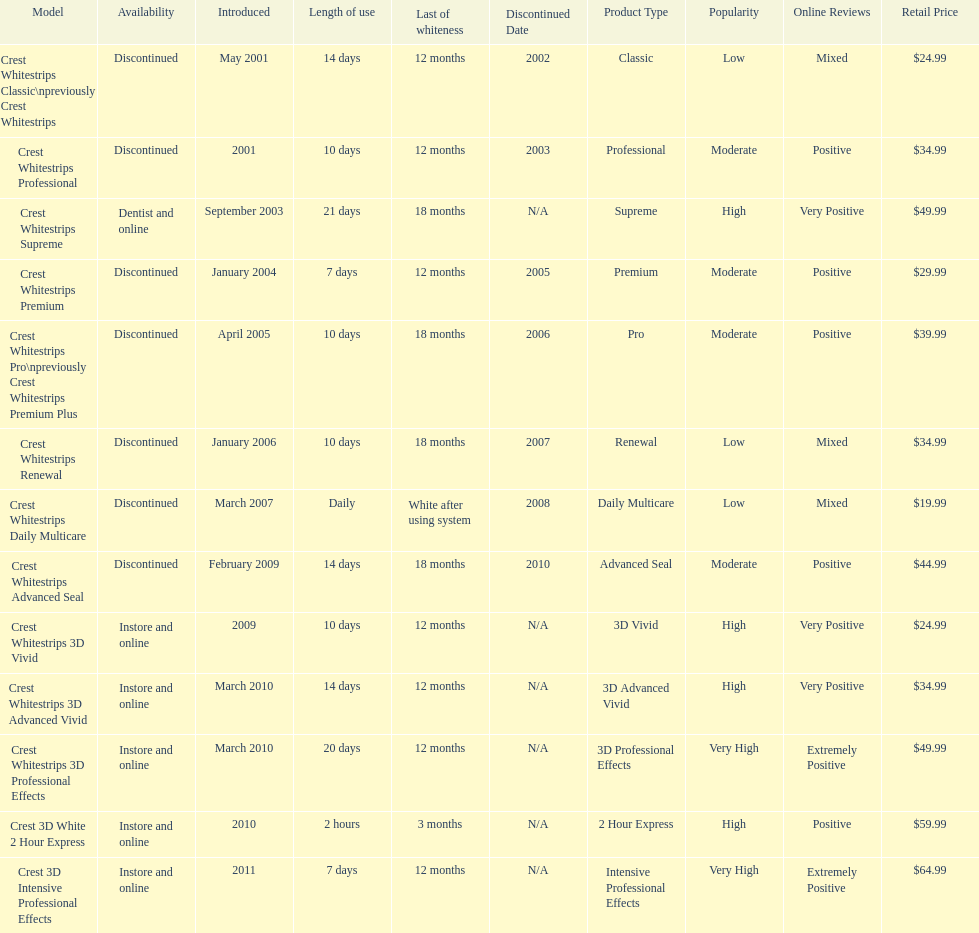Tell me the number of products that give you 12 months of whiteness. 7. 